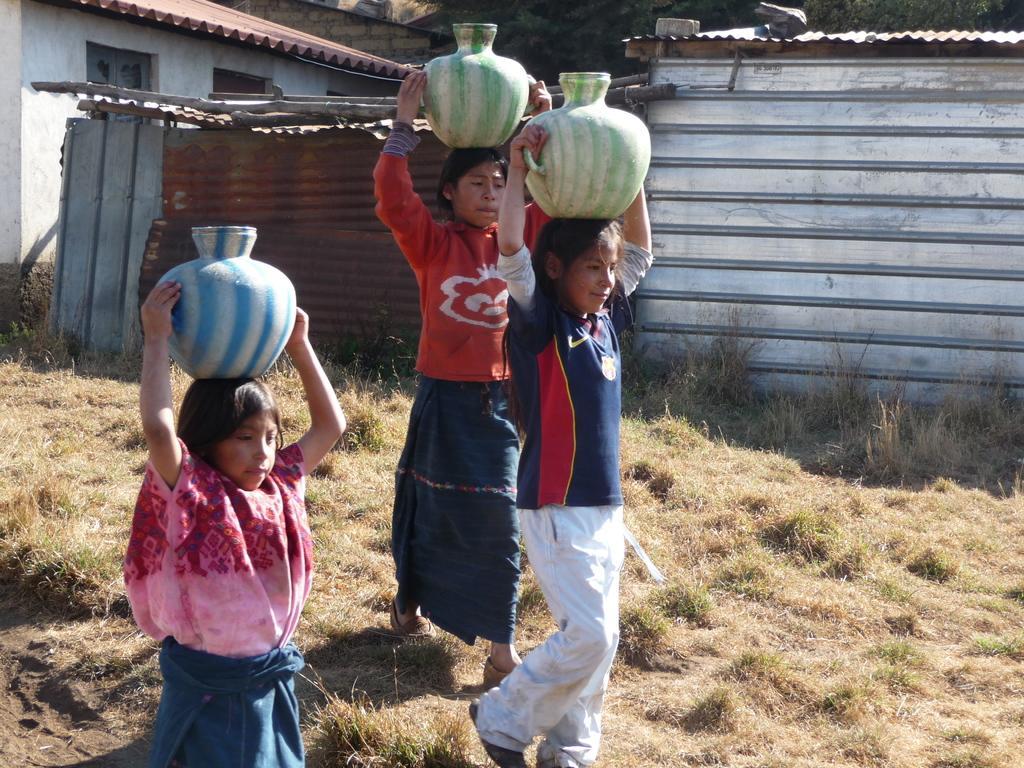Please provide a concise description of this image. In this image, in the middle there is a girl, she is walking, she is holding a pot, behind her there is a girl, she is walking, she is holding a pot. On the left there is a girl, she is holding a pot. At the bottom there is grass. In the background there are houses, trees, sheds and a wall. 